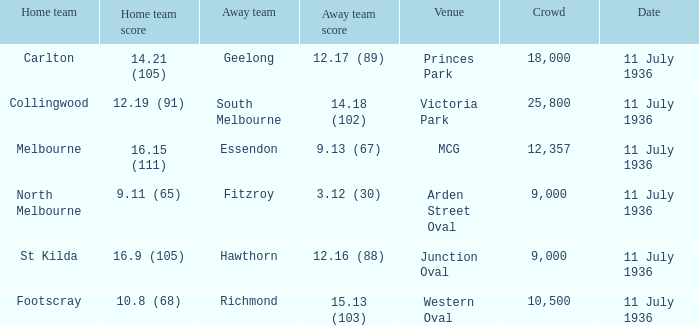What Away team got a team score of 12.16 (88)? Hawthorn. 